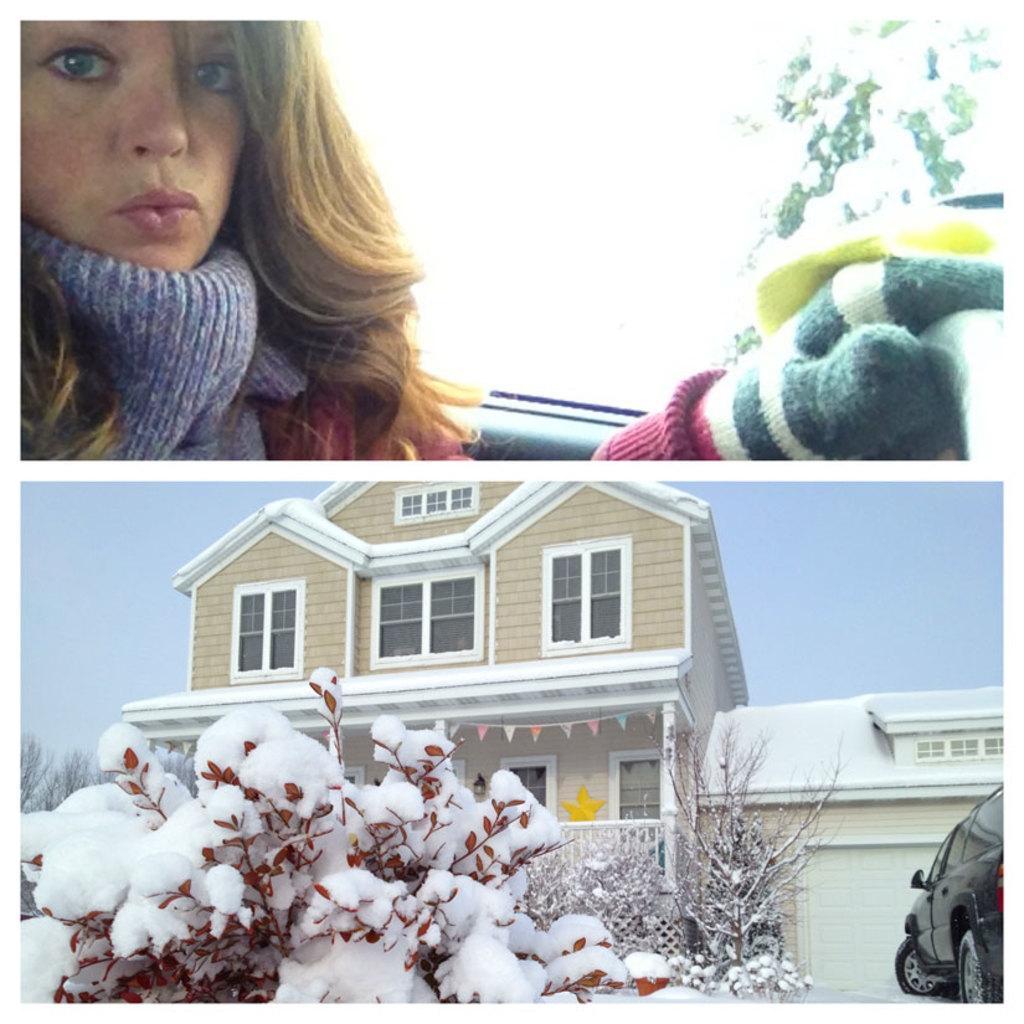Could you give a brief overview of what you see in this image? In this picture I can see the collage image. I can see the house, trees, snow and car in the parking space near to house in it. I can see the face of a person in it. 